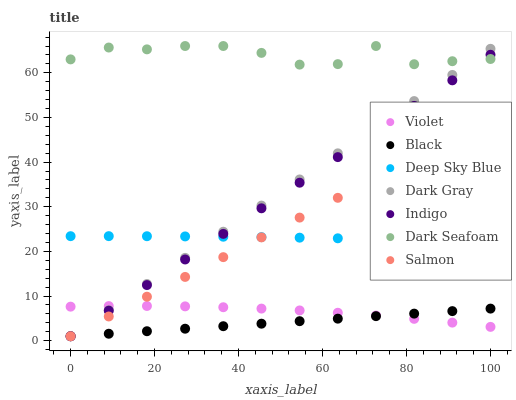Does Black have the minimum area under the curve?
Answer yes or no. Yes. Does Dark Seafoam have the maximum area under the curve?
Answer yes or no. Yes. Does Salmon have the minimum area under the curve?
Answer yes or no. No. Does Salmon have the maximum area under the curve?
Answer yes or no. No. Is Black the smoothest?
Answer yes or no. Yes. Is Dark Seafoam the roughest?
Answer yes or no. Yes. Is Salmon the smoothest?
Answer yes or no. No. Is Salmon the roughest?
Answer yes or no. No. Does Indigo have the lowest value?
Answer yes or no. Yes. Does Dark Seafoam have the lowest value?
Answer yes or no. No. Does Dark Seafoam have the highest value?
Answer yes or no. Yes. Does Salmon have the highest value?
Answer yes or no. No. Is Violet less than Deep Sky Blue?
Answer yes or no. Yes. Is Dark Seafoam greater than Salmon?
Answer yes or no. Yes. Does Black intersect Salmon?
Answer yes or no. Yes. Is Black less than Salmon?
Answer yes or no. No. Is Black greater than Salmon?
Answer yes or no. No. Does Violet intersect Deep Sky Blue?
Answer yes or no. No. 